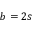<formula> <loc_0><loc_0><loc_500><loc_500>b = 2 s</formula> 